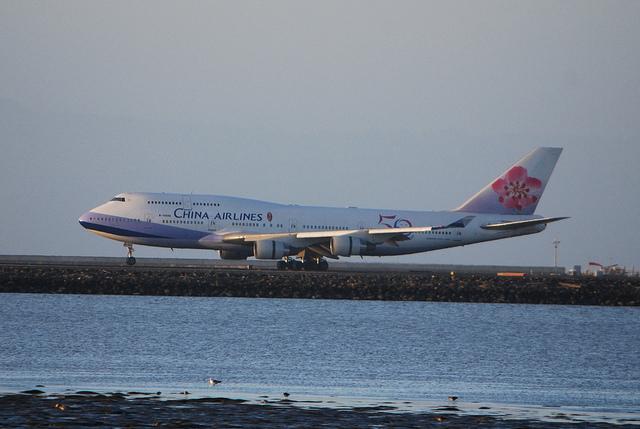What does it say on the side of the plane?
Be succinct. China airlines. Will the plane land in the water?
Answer briefly. No. What country is this plane headed to?
Answer briefly. China. What type of plane is this?
Short answer required. Passenger. Might the geologic formation, below, be an example of tectonic plate activity?
Short answer required. No. Who represents this plane?
Give a very brief answer. China airlines. What color is the smoke on top?
Short answer required. White. What is written on the plane?
Be succinct. China airlines. Is this a commercial flight?
Give a very brief answer. Yes. Is this a jumbo?
Give a very brief answer. Yes. Is this plane taking off?
Write a very short answer. No. How many planes are on the water?
Give a very brief answer. 0. What company uses this plane?
Give a very brief answer. China airlines. Why is the plane in the water?
Quick response, please. It is not. Is this plane on a runway?
Be succinct. No. Does the plane belong to an American airline?
Be succinct. No. What airline does this plane belong to?
Answer briefly. China airlines. 